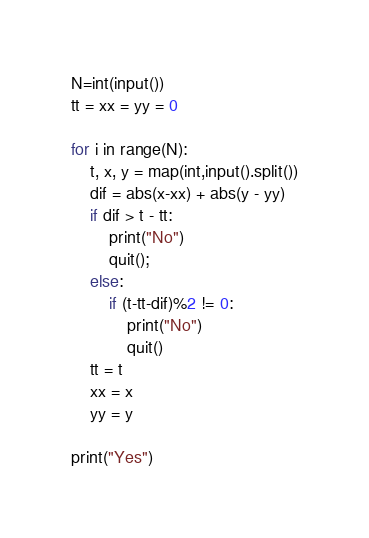Convert code to text. <code><loc_0><loc_0><loc_500><loc_500><_Python_>N=int(input())
tt = xx = yy = 0

for i in range(N):
    t, x, y = map(int,input().split())
    dif = abs(x-xx) + abs(y - yy)
    if dif > t - tt:
        print("No")
        quit();
    else:
        if (t-tt-dif)%2 != 0:
            print("No")
            quit()
    tt = t
    xx = x
    yy = y

print("Yes")</code> 